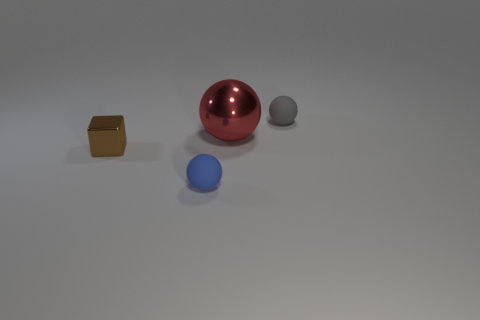What color is the rubber sphere in front of the gray thing?
Offer a terse response. Blue. How many big metallic things are there?
Offer a very short reply. 1. There is a metal object on the right side of the blue object that is right of the brown metallic object; are there any tiny brown things to the right of it?
Offer a terse response. No. What is the shape of the blue matte thing that is the same size as the brown cube?
Your answer should be very brief. Sphere. How many other things are the same color as the metal ball?
Ensure brevity in your answer.  0. What material is the blue thing?
Give a very brief answer. Rubber. How many other things are there of the same material as the gray thing?
Your answer should be very brief. 1. How big is the ball that is both left of the gray thing and behind the brown object?
Offer a terse response. Large. What is the shape of the matte object on the left side of the tiny thing that is on the right side of the blue sphere?
Give a very brief answer. Sphere. Is there anything else that has the same shape as the red metal thing?
Offer a terse response. Yes. 